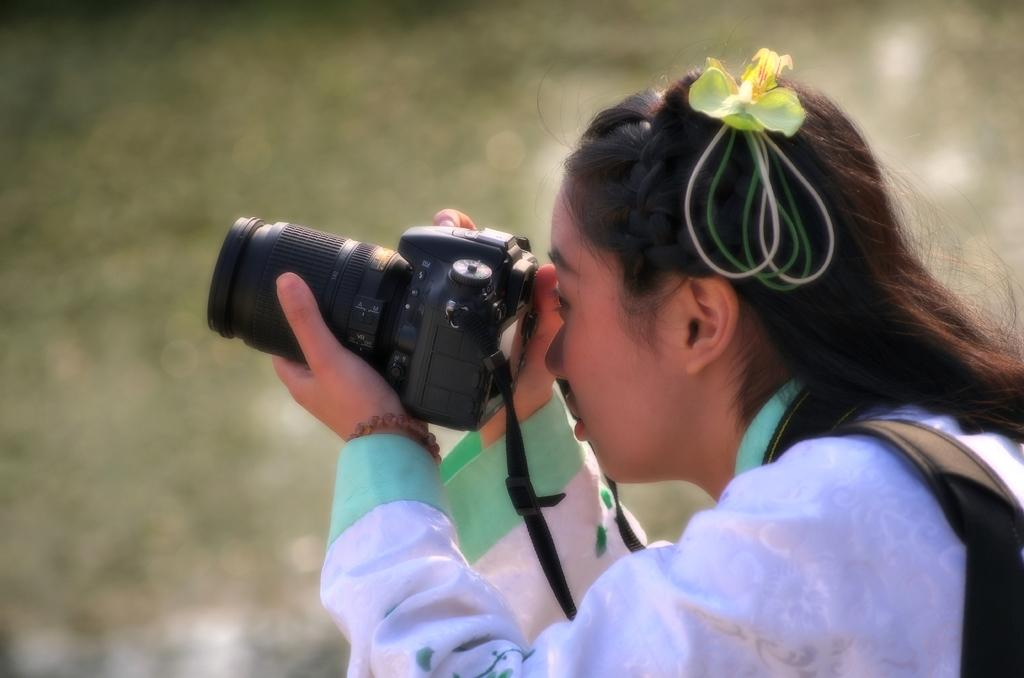Who is present in the image? There is a woman in the image. What is the woman holding in the image? The woman is holding a camera. What type of sofa is visible in the image? There is no sofa present in the image. What letters are being offered to the woman in the image? There are no letters being offered to the woman in the image. 